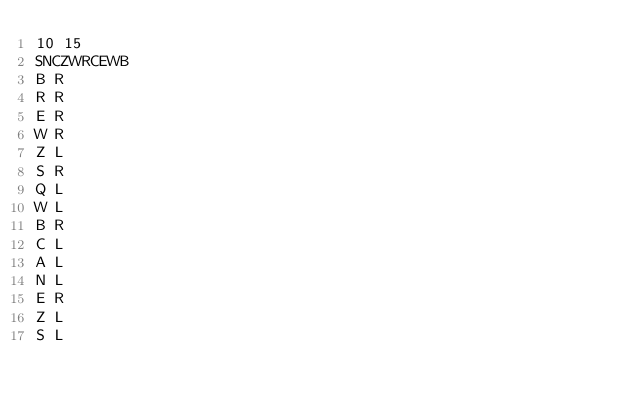Convert code to text. <code><loc_0><loc_0><loc_500><loc_500><_Python_>10 15
SNCZWRCEWB
B R
R R
E R
W R
Z L
S R
Q L
W L
B R
C L
A L
N L
E R
Z L
S L</code> 